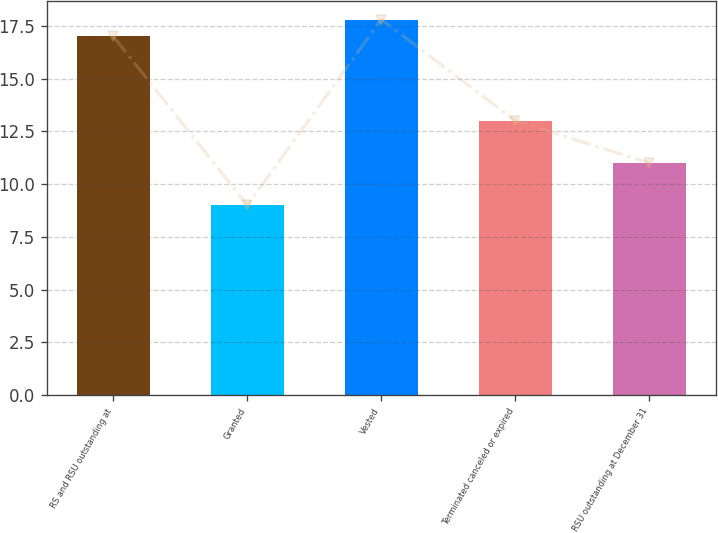Convert chart. <chart><loc_0><loc_0><loc_500><loc_500><bar_chart><fcel>RS and RSU outstanding at<fcel>Granted<fcel>Vested<fcel>Terminated canceled or expired<fcel>RSU outstanding at December 31<nl><fcel>17<fcel>9<fcel>17.8<fcel>13<fcel>11<nl></chart> 